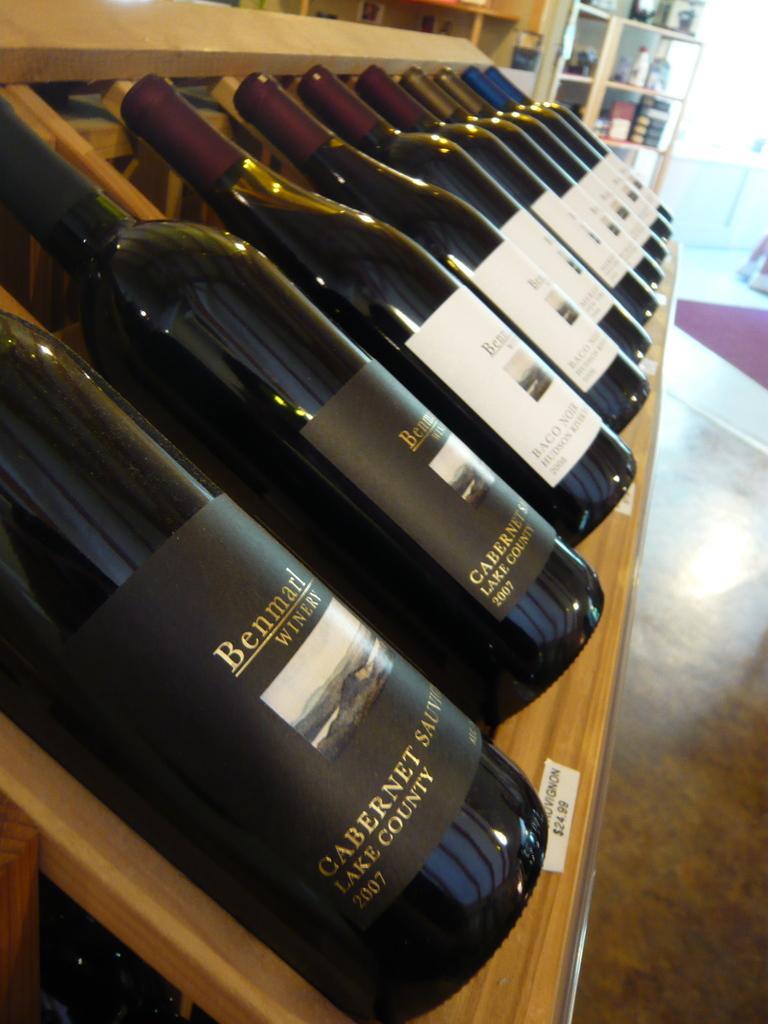Could you give a brief overview of what you see in this image? In this image I can see few bottles on the wooden surface, background I can see few bottles on the wooden rack. 